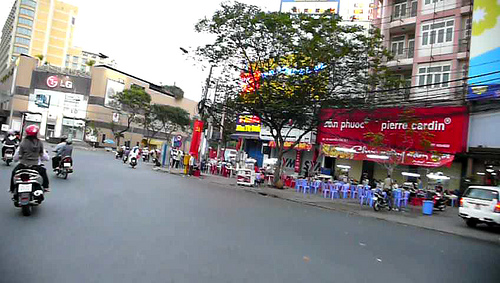Is the store the same color as the chair? No, the store and the chair are not the same color; the store is red, whereas the chair is blue. 